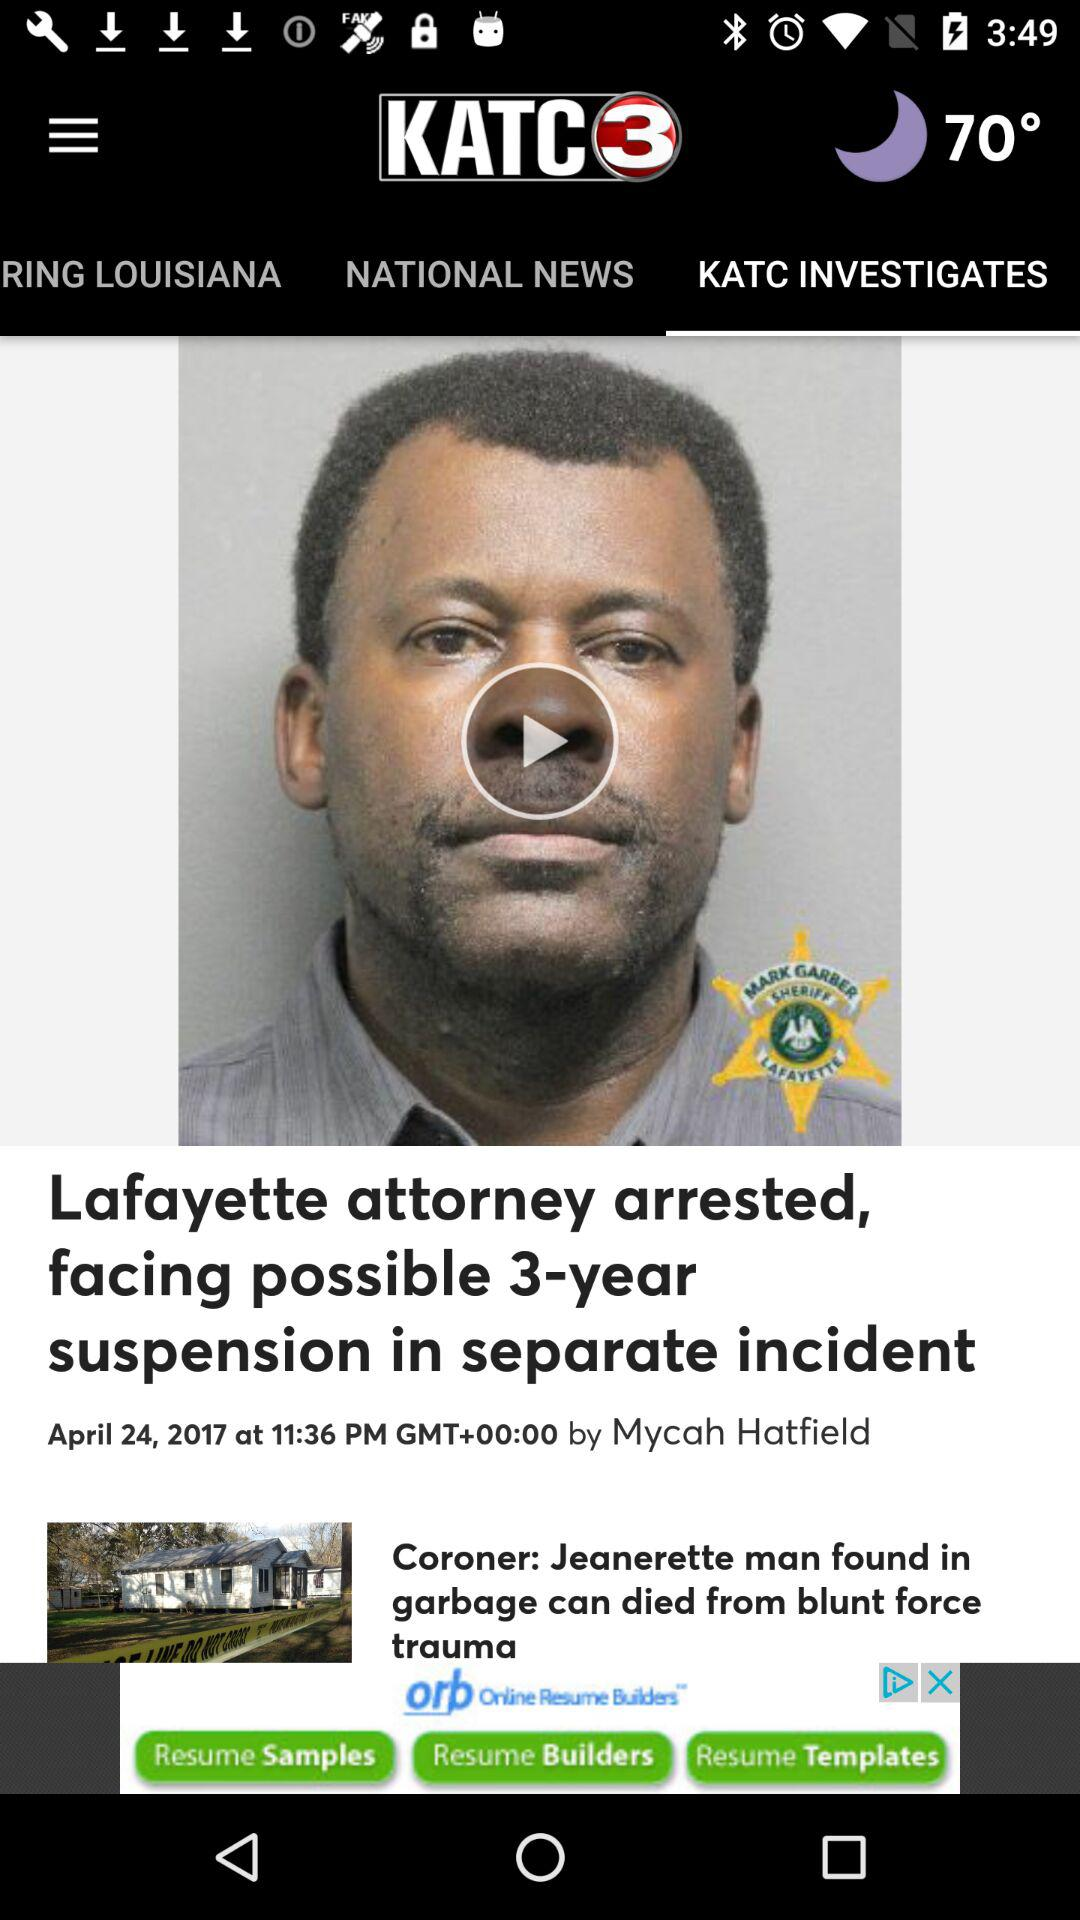What is the shown temperature? The shown temperature is 70°. 